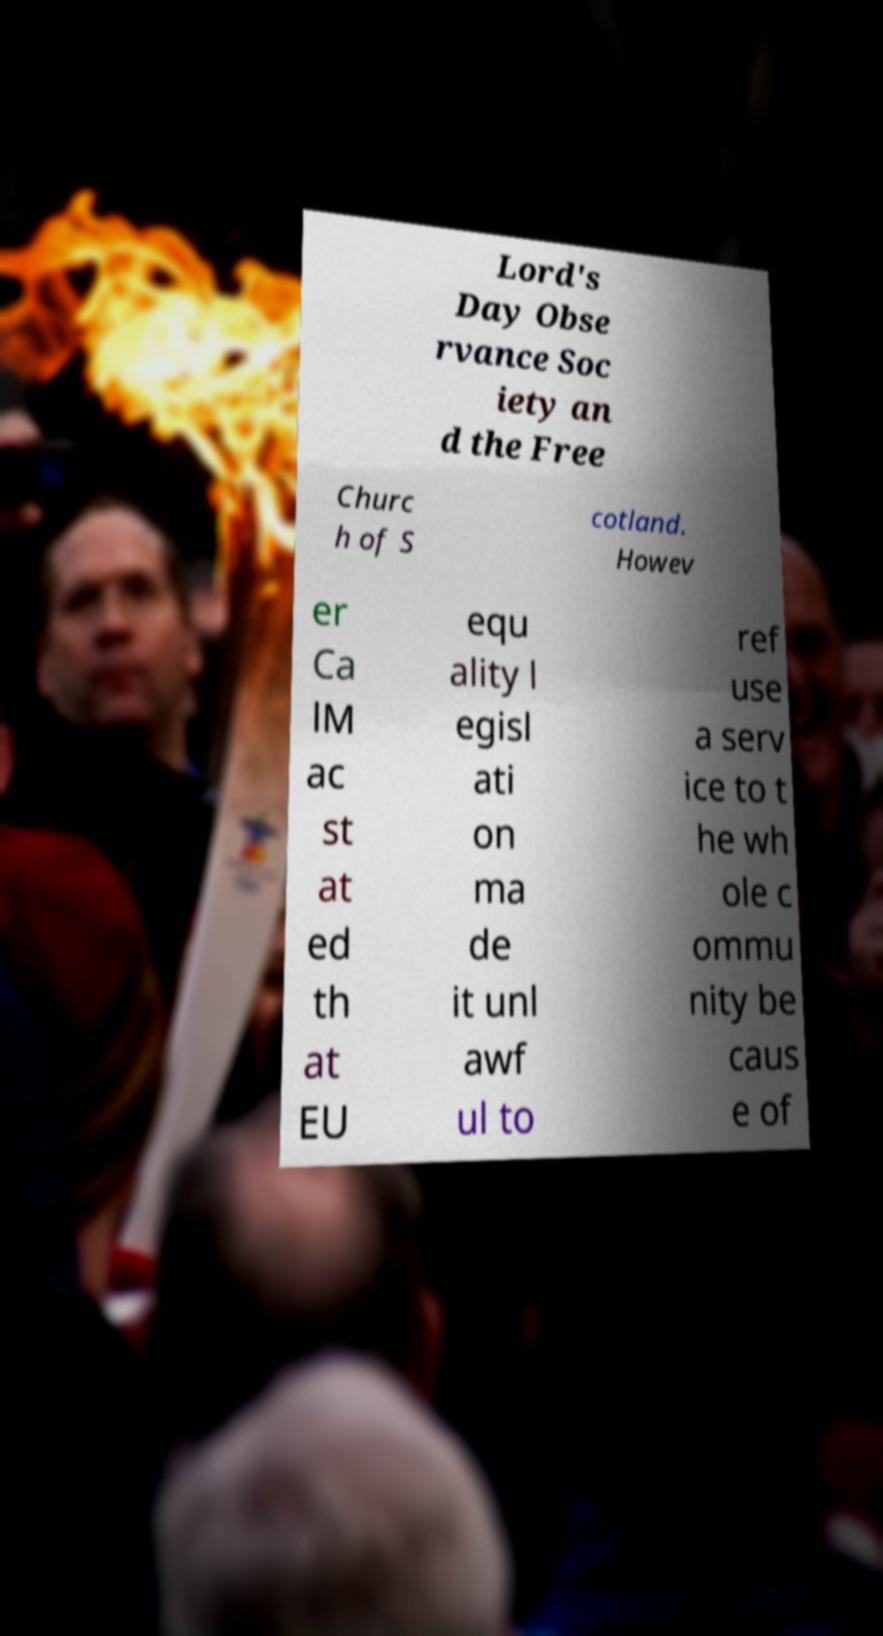Please identify and transcribe the text found in this image. Lord's Day Obse rvance Soc iety an d the Free Churc h of S cotland. Howev er Ca lM ac st at ed th at EU equ ality l egisl ati on ma de it unl awf ul to ref use a serv ice to t he wh ole c ommu nity be caus e of 